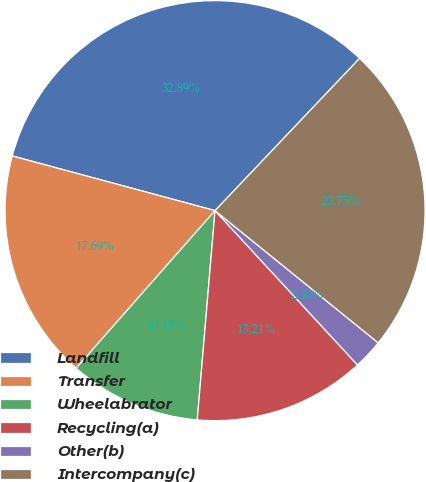Convert chart to OTSL. <chart><loc_0><loc_0><loc_500><loc_500><pie_chart><fcel>Landfill<fcel>Transfer<fcel>Wheelabrator<fcel>Recycling(a)<fcel>Other(b)<fcel>Intercompany(c)<nl><fcel>32.89%<fcel>17.69%<fcel>10.15%<fcel>13.21%<fcel>2.3%<fcel>23.75%<nl></chart> 